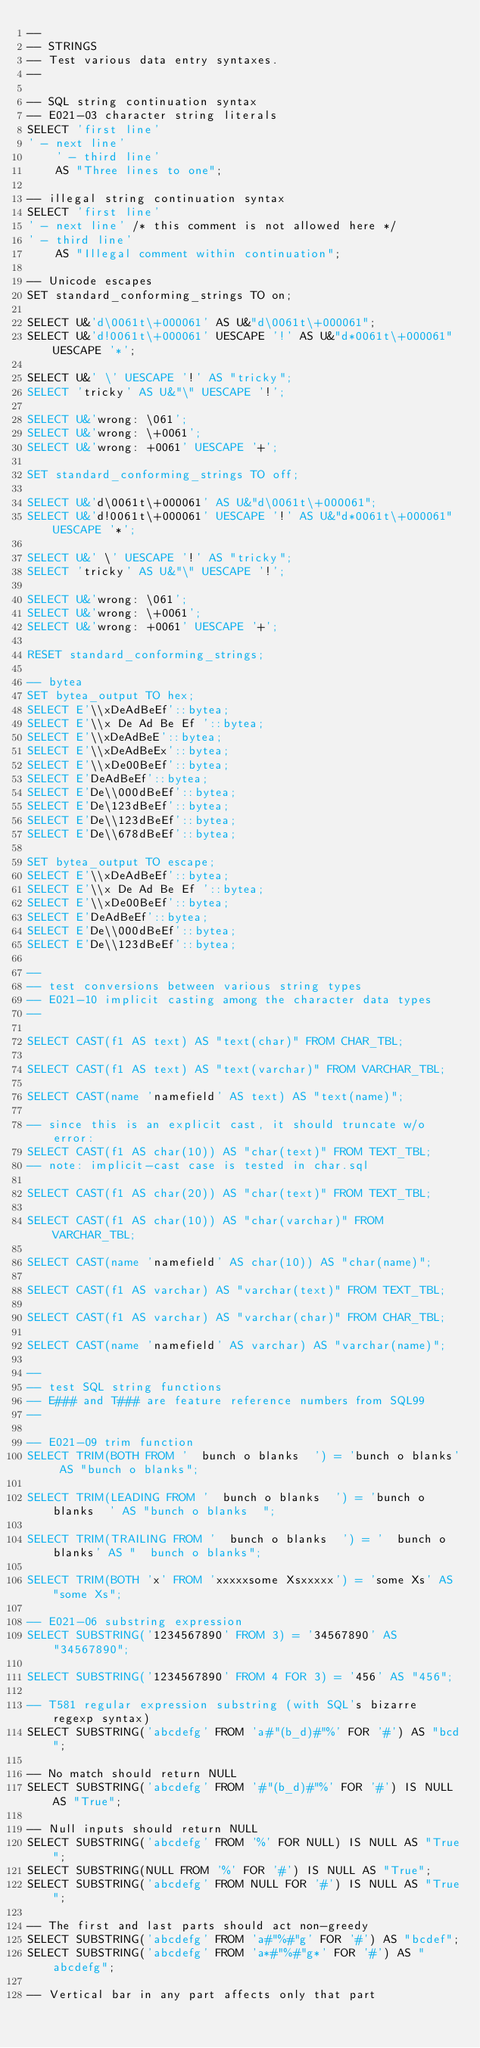Convert code to text. <code><loc_0><loc_0><loc_500><loc_500><_SQL_>--
-- STRINGS
-- Test various data entry syntaxes.
--

-- SQL string continuation syntax
-- E021-03 character string literals
SELECT 'first line'
' - next line'
	' - third line'
	AS "Three lines to one";

-- illegal string continuation syntax
SELECT 'first line'
' - next line' /* this comment is not allowed here */
' - third line'
	AS "Illegal comment within continuation";

-- Unicode escapes
SET standard_conforming_strings TO on;

SELECT U&'d\0061t\+000061' AS U&"d\0061t\+000061";
SELECT U&'d!0061t\+000061' UESCAPE '!' AS U&"d*0061t\+000061" UESCAPE '*';

SELECT U&' \' UESCAPE '!' AS "tricky";
SELECT 'tricky' AS U&"\" UESCAPE '!';

SELECT U&'wrong: \061';
SELECT U&'wrong: \+0061';
SELECT U&'wrong: +0061' UESCAPE '+';

SET standard_conforming_strings TO off;

SELECT U&'d\0061t\+000061' AS U&"d\0061t\+000061";
SELECT U&'d!0061t\+000061' UESCAPE '!' AS U&"d*0061t\+000061" UESCAPE '*';

SELECT U&' \' UESCAPE '!' AS "tricky";
SELECT 'tricky' AS U&"\" UESCAPE '!';

SELECT U&'wrong: \061';
SELECT U&'wrong: \+0061';
SELECT U&'wrong: +0061' UESCAPE '+';

RESET standard_conforming_strings;

-- bytea
SET bytea_output TO hex;
SELECT E'\\xDeAdBeEf'::bytea;
SELECT E'\\x De Ad Be Ef '::bytea;
SELECT E'\\xDeAdBeE'::bytea;
SELECT E'\\xDeAdBeEx'::bytea;
SELECT E'\\xDe00BeEf'::bytea;
SELECT E'DeAdBeEf'::bytea;
SELECT E'De\\000dBeEf'::bytea;
SELECT E'De\123dBeEf'::bytea;
SELECT E'De\\123dBeEf'::bytea;
SELECT E'De\\678dBeEf'::bytea;

SET bytea_output TO escape;
SELECT E'\\xDeAdBeEf'::bytea;
SELECT E'\\x De Ad Be Ef '::bytea;
SELECT E'\\xDe00BeEf'::bytea;
SELECT E'DeAdBeEf'::bytea;
SELECT E'De\\000dBeEf'::bytea;
SELECT E'De\\123dBeEf'::bytea;

--
-- test conversions between various string types
-- E021-10 implicit casting among the character data types
--

SELECT CAST(f1 AS text) AS "text(char)" FROM CHAR_TBL;

SELECT CAST(f1 AS text) AS "text(varchar)" FROM VARCHAR_TBL;

SELECT CAST(name 'namefield' AS text) AS "text(name)";

-- since this is an explicit cast, it should truncate w/o error:
SELECT CAST(f1 AS char(10)) AS "char(text)" FROM TEXT_TBL;
-- note: implicit-cast case is tested in char.sql

SELECT CAST(f1 AS char(20)) AS "char(text)" FROM TEXT_TBL;

SELECT CAST(f1 AS char(10)) AS "char(varchar)" FROM VARCHAR_TBL;

SELECT CAST(name 'namefield' AS char(10)) AS "char(name)";

SELECT CAST(f1 AS varchar) AS "varchar(text)" FROM TEXT_TBL;

SELECT CAST(f1 AS varchar) AS "varchar(char)" FROM CHAR_TBL;

SELECT CAST(name 'namefield' AS varchar) AS "varchar(name)";

--
-- test SQL string functions
-- E### and T### are feature reference numbers from SQL99
--

-- E021-09 trim function
SELECT TRIM(BOTH FROM '  bunch o blanks  ') = 'bunch o blanks' AS "bunch o blanks";

SELECT TRIM(LEADING FROM '  bunch o blanks  ') = 'bunch o blanks  ' AS "bunch o blanks  ";

SELECT TRIM(TRAILING FROM '  bunch o blanks  ') = '  bunch o blanks' AS "  bunch o blanks";

SELECT TRIM(BOTH 'x' FROM 'xxxxxsome Xsxxxxx') = 'some Xs' AS "some Xs";

-- E021-06 substring expression
SELECT SUBSTRING('1234567890' FROM 3) = '34567890' AS "34567890";

SELECT SUBSTRING('1234567890' FROM 4 FOR 3) = '456' AS "456";

-- T581 regular expression substring (with SQL's bizarre regexp syntax)
SELECT SUBSTRING('abcdefg' FROM 'a#"(b_d)#"%' FOR '#') AS "bcd";

-- No match should return NULL
SELECT SUBSTRING('abcdefg' FROM '#"(b_d)#"%' FOR '#') IS NULL AS "True";

-- Null inputs should return NULL
SELECT SUBSTRING('abcdefg' FROM '%' FOR NULL) IS NULL AS "True";
SELECT SUBSTRING(NULL FROM '%' FOR '#') IS NULL AS "True";
SELECT SUBSTRING('abcdefg' FROM NULL FOR '#') IS NULL AS "True";

-- The first and last parts should act non-greedy
SELECT SUBSTRING('abcdefg' FROM 'a#"%#"g' FOR '#') AS "bcdef";
SELECT SUBSTRING('abcdefg' FROM 'a*#"%#"g*' FOR '#') AS "abcdefg";

-- Vertical bar in any part affects only that part</code> 